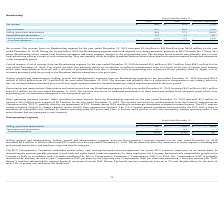According to Hc2 Holdings's financial document, What was the selling, general and administrative expense for the year ended December 31, 2019? According to the financial document, $24.9 million. The relevant text states: "ended December 31, 2019 decreased $8.6 million to $24.9 million from $33.5 million for the year ended December 31, 2018. The decrease was driven by reductions in bo..." Also, What is the hurdle rate? According to the financial document, 7%. The relevant text states: "turn. The hurdle rate has consistently been set at 7%, and the plan allows for the share of up to 12% of growth over and above the hurdle rate...." Also, What was the percentage decrease in NAV in 2019? Based on the financial document, the answer is 26.1%. Also, can you calculate: What was the percentage change in the selling, general and administrative expenses from 2018 to 2019? To answer this question, I need to perform calculations using the financial data. The calculation is: 24.9 / 33.5 - 1, which equals -25.67 (percentage). This is based on the information: "Selling, general and administrative $ 24.9 $ 33.5 $ (8.6) Selling, general and administrative $ 24.9 $ 33.5 $ (8.6)..." The key data points involved are: 24.9, 33.5. Also, can you calculate: What is the average depreciation and amortization expense for 2018 and 2019? To answer this question, I need to perform calculations using the financial data. The calculation is: (0.1 + 0.1) / 2, which equals 0.1 (in millions). This is based on the information: "Depreciation and amortization 0.1 0.1 —..." Also, can you calculate: What is the percentage change in the loss from operations from 2018 to 2019? To answer this question, I need to perform calculations using the financial data. The calculation is: -25.0 / -33.6 - 1, which equals -0.26 (percentage). This is based on the information: "Loss from operations $ (25.0) $ (33.6) $ 8.6 Loss from operations $ (25.0) $ (33.6) $ 8.6..." The key data points involved are: 25.0, 33.6. 